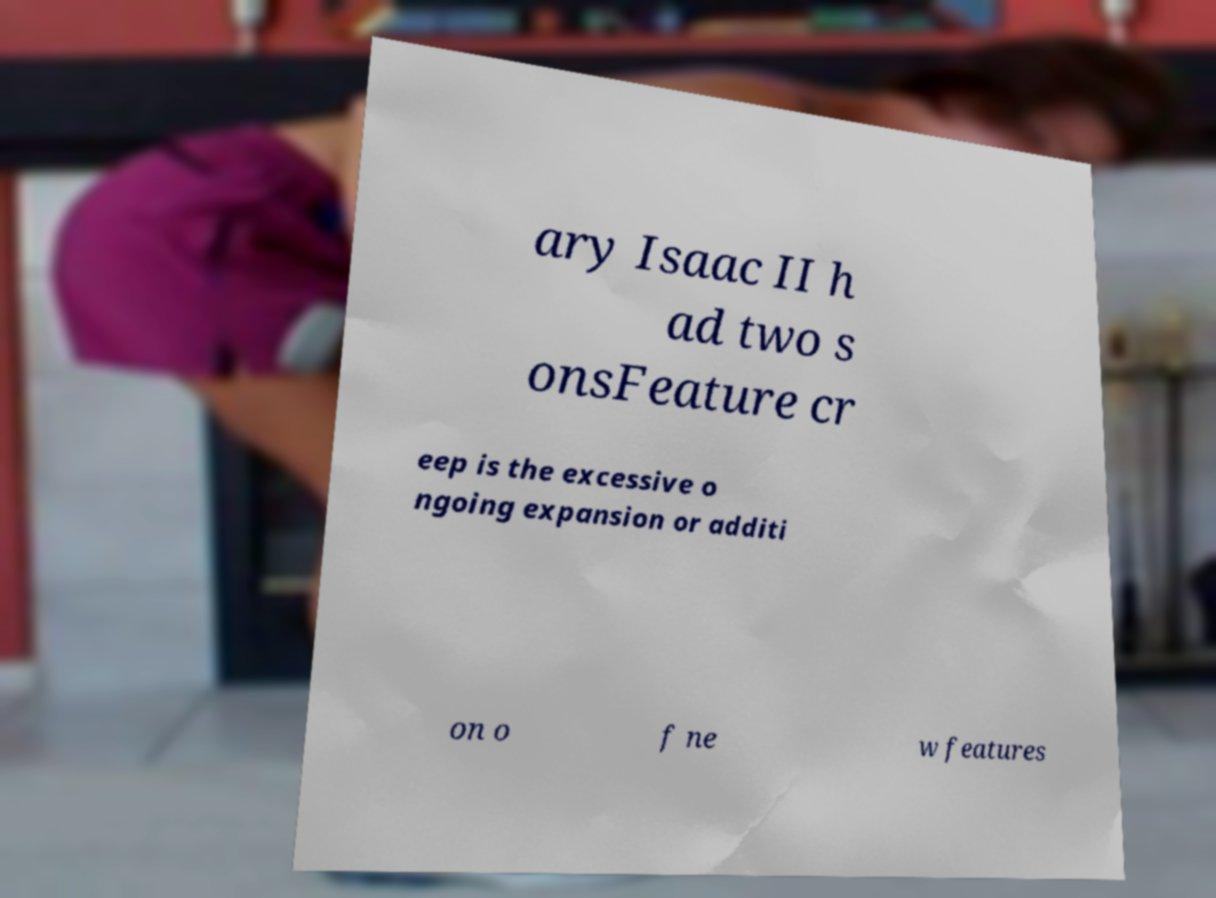Can you read and provide the text displayed in the image?This photo seems to have some interesting text. Can you extract and type it out for me? ary Isaac II h ad two s onsFeature cr eep is the excessive o ngoing expansion or additi on o f ne w features 